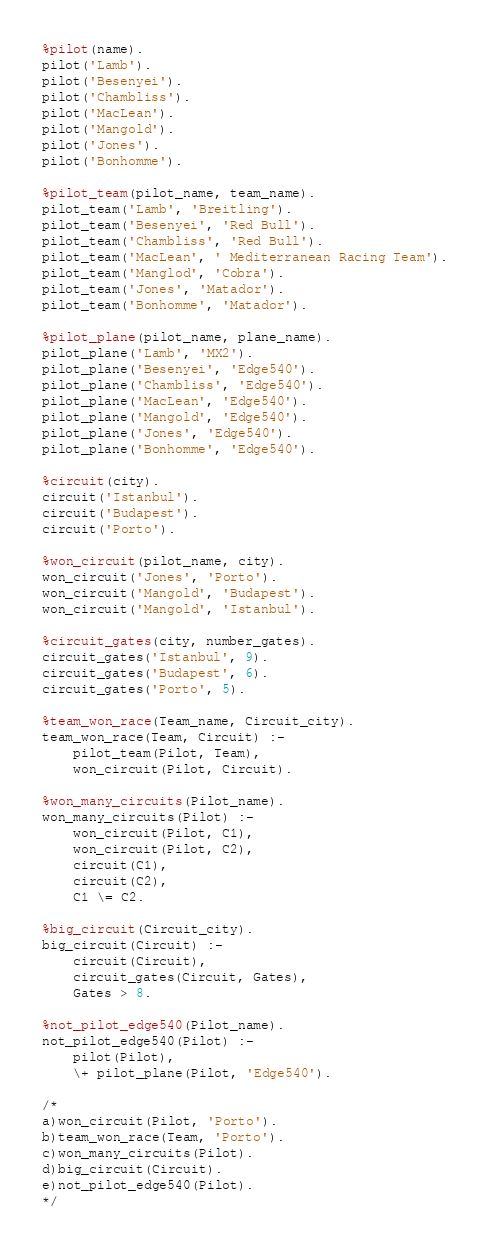Convert code to text. <code><loc_0><loc_0><loc_500><loc_500><_Perl_>%pilot(name).
pilot('Lamb').
pilot('Besenyei').
pilot('Chambliss').
pilot('MacLean').
pilot('Mangold').
pilot('Jones').
pilot('Bonhomme').

%pilot_team(pilot_name, team_name).
pilot_team('Lamb', 'Breitling').
pilot_team('Besenyei', 'Red Bull').
pilot_team('Chambliss', 'Red Bull').
pilot_team('MacLean', ' Mediterranean Racing Team').
pilot_team('Manglod', 'Cobra').
pilot_team('Jones', 'Matador').
pilot_team('Bonhomme', 'Matador').

%pilot_plane(pilot_name, plane_name).
pilot_plane('Lamb', 'MX2').
pilot_plane('Besenyei', 'Edge540'). 
pilot_plane('Chambliss', 'Edge540').  
pilot_plane('MacLean', 'Edge540').
pilot_plane('Mangold', 'Edge540').
pilot_plane('Jones', 'Edge540'). 
pilot_plane('Bonhomme', 'Edge540').

%circuit(city).
circuit('Istanbul').
circuit('Budapest').
circuit('Porto').

%won_circuit(pilot_name, city).
won_circuit('Jones', 'Porto').
won_circuit('Mangold', 'Budapest').
won_circuit('Mangold', 'Istanbul').

%circuit_gates(city, number_gates).
circuit_gates('Istanbul', 9).
circuit_gates('Budapest', 6).
circuit_gates('Porto', 5).

%team_won_race(Team_name, Circuit_city).
team_won_race(Team, Circuit) :-
    pilot_team(Pilot, Team),
    won_circuit(Pilot, Circuit).

%won_many_circuits(Pilot_name).
won_many_circuits(Pilot) :-
    won_circuit(Pilot, C1),
    won_circuit(Pilot, C2),
    circuit(C1),
    circuit(C2),
    C1 \= C2.

%big_circuit(Circuit_city).
big_circuit(Circuit) :-
    circuit(Circuit),
    circuit_gates(Circuit, Gates),
    Gates > 8.

%not_pilot_edge540(Pilot_name).
not_pilot_edge540(Pilot) :-
    pilot(Pilot),
    \+ pilot_plane(Pilot, 'Edge540').

/*
a)won_circuit(Pilot, 'Porto').
b)team_won_race(Team, 'Porto').
c)won_many_circuits(Pilot).
d)big_circuit(Circuit).
e)not_pilot_edge540(Pilot).
*/</code> 